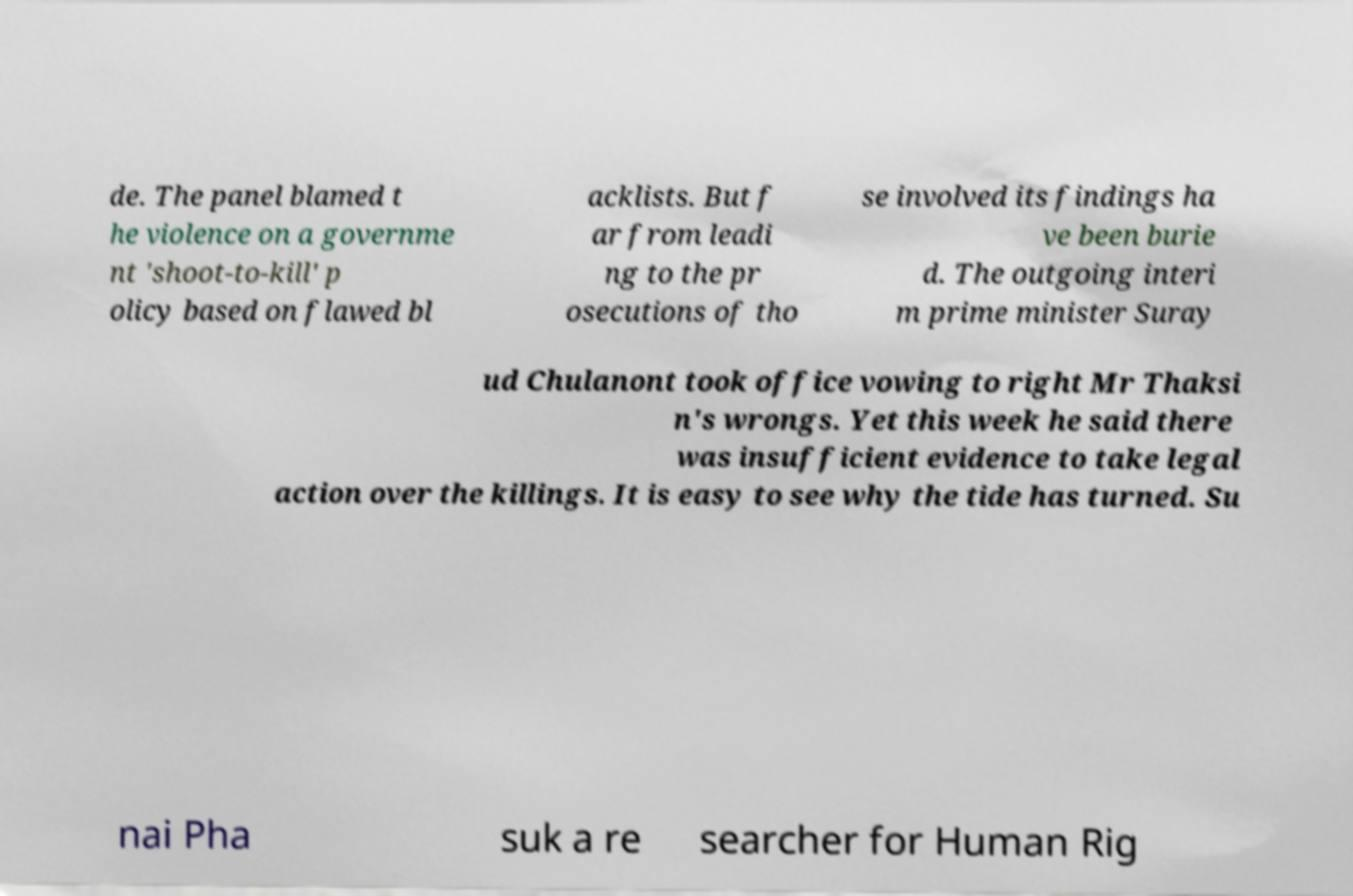Can you accurately transcribe the text from the provided image for me? de. The panel blamed t he violence on a governme nt 'shoot-to-kill' p olicy based on flawed bl acklists. But f ar from leadi ng to the pr osecutions of tho se involved its findings ha ve been burie d. The outgoing interi m prime minister Suray ud Chulanont took office vowing to right Mr Thaksi n's wrongs. Yet this week he said there was insufficient evidence to take legal action over the killings. It is easy to see why the tide has turned. Su nai Pha suk a re searcher for Human Rig 